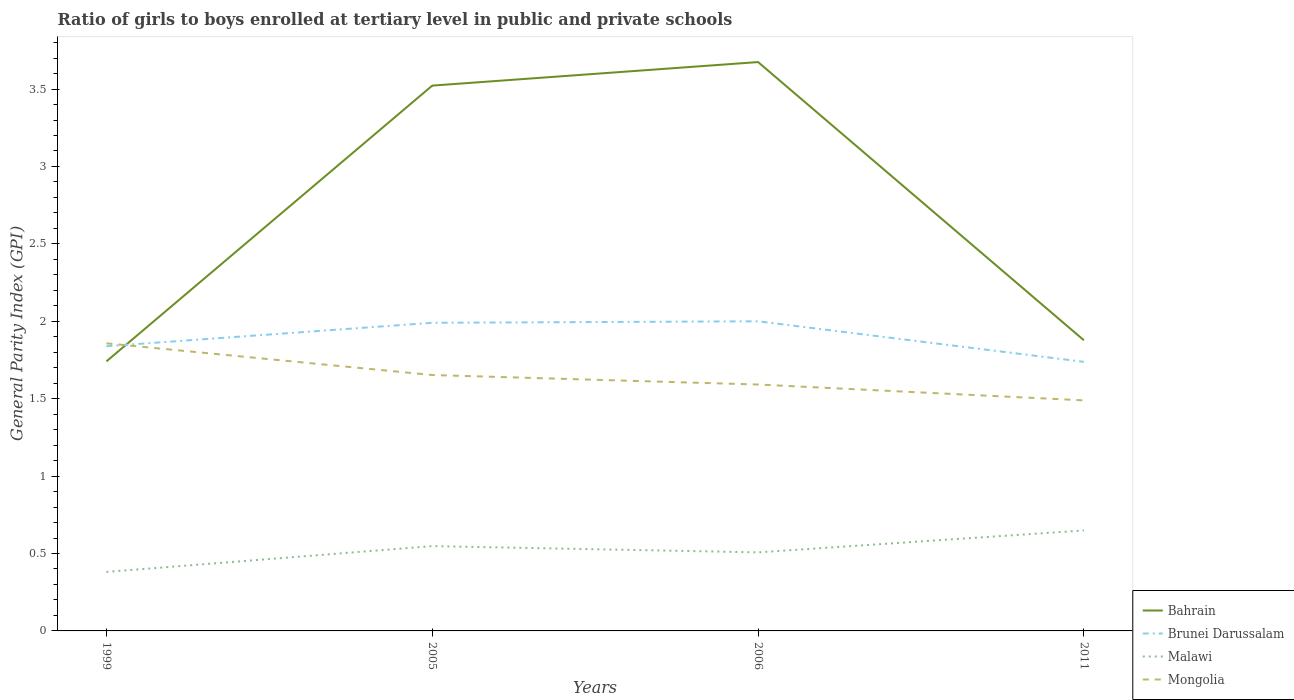How many different coloured lines are there?
Make the answer very short. 4. Is the number of lines equal to the number of legend labels?
Your answer should be very brief. Yes. Across all years, what is the maximum general parity index in Mongolia?
Your response must be concise. 1.49. In which year was the general parity index in Mongolia maximum?
Your response must be concise. 2011. What is the total general parity index in Brunei Darussalam in the graph?
Provide a short and direct response. 0.26. What is the difference between the highest and the second highest general parity index in Mongolia?
Keep it short and to the point. 0.37. Is the general parity index in Bahrain strictly greater than the general parity index in Malawi over the years?
Make the answer very short. No. How many lines are there?
Your response must be concise. 4. How many years are there in the graph?
Provide a succinct answer. 4. What is the difference between two consecutive major ticks on the Y-axis?
Provide a succinct answer. 0.5. Where does the legend appear in the graph?
Your answer should be very brief. Bottom right. How many legend labels are there?
Provide a short and direct response. 4. How are the legend labels stacked?
Ensure brevity in your answer.  Vertical. What is the title of the graph?
Your response must be concise. Ratio of girls to boys enrolled at tertiary level in public and private schools. What is the label or title of the Y-axis?
Your answer should be compact. General Parity Index (GPI). What is the General Parity Index (GPI) in Bahrain in 1999?
Your answer should be very brief. 1.74. What is the General Parity Index (GPI) of Brunei Darussalam in 1999?
Offer a very short reply. 1.84. What is the General Parity Index (GPI) in Malawi in 1999?
Your answer should be compact. 0.38. What is the General Parity Index (GPI) of Mongolia in 1999?
Your answer should be compact. 1.86. What is the General Parity Index (GPI) in Bahrain in 2005?
Offer a terse response. 3.52. What is the General Parity Index (GPI) of Brunei Darussalam in 2005?
Your response must be concise. 1.99. What is the General Parity Index (GPI) in Malawi in 2005?
Offer a very short reply. 0.55. What is the General Parity Index (GPI) in Mongolia in 2005?
Give a very brief answer. 1.65. What is the General Parity Index (GPI) in Bahrain in 2006?
Ensure brevity in your answer.  3.67. What is the General Parity Index (GPI) in Brunei Darussalam in 2006?
Ensure brevity in your answer.  2. What is the General Parity Index (GPI) in Malawi in 2006?
Ensure brevity in your answer.  0.51. What is the General Parity Index (GPI) in Mongolia in 2006?
Your answer should be very brief. 1.59. What is the General Parity Index (GPI) of Bahrain in 2011?
Make the answer very short. 1.88. What is the General Parity Index (GPI) in Brunei Darussalam in 2011?
Ensure brevity in your answer.  1.74. What is the General Parity Index (GPI) of Malawi in 2011?
Make the answer very short. 0.65. What is the General Parity Index (GPI) of Mongolia in 2011?
Your response must be concise. 1.49. Across all years, what is the maximum General Parity Index (GPI) in Bahrain?
Keep it short and to the point. 3.67. Across all years, what is the maximum General Parity Index (GPI) of Brunei Darussalam?
Offer a terse response. 2. Across all years, what is the maximum General Parity Index (GPI) in Malawi?
Make the answer very short. 0.65. Across all years, what is the maximum General Parity Index (GPI) of Mongolia?
Provide a short and direct response. 1.86. Across all years, what is the minimum General Parity Index (GPI) in Bahrain?
Your response must be concise. 1.74. Across all years, what is the minimum General Parity Index (GPI) of Brunei Darussalam?
Make the answer very short. 1.74. Across all years, what is the minimum General Parity Index (GPI) of Malawi?
Ensure brevity in your answer.  0.38. Across all years, what is the minimum General Parity Index (GPI) of Mongolia?
Give a very brief answer. 1.49. What is the total General Parity Index (GPI) in Bahrain in the graph?
Your answer should be compact. 10.82. What is the total General Parity Index (GPI) in Brunei Darussalam in the graph?
Give a very brief answer. 7.57. What is the total General Parity Index (GPI) of Malawi in the graph?
Make the answer very short. 2.09. What is the total General Parity Index (GPI) in Mongolia in the graph?
Offer a very short reply. 6.59. What is the difference between the General Parity Index (GPI) of Bahrain in 1999 and that in 2005?
Your answer should be compact. -1.78. What is the difference between the General Parity Index (GPI) in Brunei Darussalam in 1999 and that in 2005?
Your answer should be compact. -0.15. What is the difference between the General Parity Index (GPI) of Malawi in 1999 and that in 2005?
Your answer should be compact. -0.17. What is the difference between the General Parity Index (GPI) in Mongolia in 1999 and that in 2005?
Provide a short and direct response. 0.2. What is the difference between the General Parity Index (GPI) in Bahrain in 1999 and that in 2006?
Provide a short and direct response. -1.93. What is the difference between the General Parity Index (GPI) of Brunei Darussalam in 1999 and that in 2006?
Offer a very short reply. -0.16. What is the difference between the General Parity Index (GPI) in Malawi in 1999 and that in 2006?
Keep it short and to the point. -0.13. What is the difference between the General Parity Index (GPI) of Mongolia in 1999 and that in 2006?
Provide a succinct answer. 0.27. What is the difference between the General Parity Index (GPI) in Bahrain in 1999 and that in 2011?
Offer a very short reply. -0.14. What is the difference between the General Parity Index (GPI) of Brunei Darussalam in 1999 and that in 2011?
Offer a very short reply. 0.1. What is the difference between the General Parity Index (GPI) of Malawi in 1999 and that in 2011?
Offer a terse response. -0.27. What is the difference between the General Parity Index (GPI) of Mongolia in 1999 and that in 2011?
Give a very brief answer. 0.37. What is the difference between the General Parity Index (GPI) of Bahrain in 2005 and that in 2006?
Offer a very short reply. -0.15. What is the difference between the General Parity Index (GPI) in Brunei Darussalam in 2005 and that in 2006?
Keep it short and to the point. -0.01. What is the difference between the General Parity Index (GPI) in Malawi in 2005 and that in 2006?
Keep it short and to the point. 0.04. What is the difference between the General Parity Index (GPI) of Mongolia in 2005 and that in 2006?
Keep it short and to the point. 0.06. What is the difference between the General Parity Index (GPI) of Bahrain in 2005 and that in 2011?
Offer a terse response. 1.64. What is the difference between the General Parity Index (GPI) of Brunei Darussalam in 2005 and that in 2011?
Ensure brevity in your answer.  0.25. What is the difference between the General Parity Index (GPI) of Malawi in 2005 and that in 2011?
Your answer should be very brief. -0.1. What is the difference between the General Parity Index (GPI) of Mongolia in 2005 and that in 2011?
Provide a short and direct response. 0.16. What is the difference between the General Parity Index (GPI) of Bahrain in 2006 and that in 2011?
Give a very brief answer. 1.8. What is the difference between the General Parity Index (GPI) of Brunei Darussalam in 2006 and that in 2011?
Provide a succinct answer. 0.26. What is the difference between the General Parity Index (GPI) in Malawi in 2006 and that in 2011?
Provide a short and direct response. -0.14. What is the difference between the General Parity Index (GPI) of Mongolia in 2006 and that in 2011?
Make the answer very short. 0.1. What is the difference between the General Parity Index (GPI) of Bahrain in 1999 and the General Parity Index (GPI) of Brunei Darussalam in 2005?
Provide a short and direct response. -0.25. What is the difference between the General Parity Index (GPI) in Bahrain in 1999 and the General Parity Index (GPI) in Malawi in 2005?
Offer a terse response. 1.19. What is the difference between the General Parity Index (GPI) in Bahrain in 1999 and the General Parity Index (GPI) in Mongolia in 2005?
Your answer should be compact. 0.09. What is the difference between the General Parity Index (GPI) of Brunei Darussalam in 1999 and the General Parity Index (GPI) of Malawi in 2005?
Give a very brief answer. 1.29. What is the difference between the General Parity Index (GPI) of Brunei Darussalam in 1999 and the General Parity Index (GPI) of Mongolia in 2005?
Offer a very short reply. 0.19. What is the difference between the General Parity Index (GPI) of Malawi in 1999 and the General Parity Index (GPI) of Mongolia in 2005?
Your answer should be compact. -1.27. What is the difference between the General Parity Index (GPI) in Bahrain in 1999 and the General Parity Index (GPI) in Brunei Darussalam in 2006?
Your answer should be compact. -0.26. What is the difference between the General Parity Index (GPI) of Bahrain in 1999 and the General Parity Index (GPI) of Malawi in 2006?
Make the answer very short. 1.23. What is the difference between the General Parity Index (GPI) in Bahrain in 1999 and the General Parity Index (GPI) in Mongolia in 2006?
Offer a very short reply. 0.15. What is the difference between the General Parity Index (GPI) in Brunei Darussalam in 1999 and the General Parity Index (GPI) in Malawi in 2006?
Provide a short and direct response. 1.33. What is the difference between the General Parity Index (GPI) in Brunei Darussalam in 1999 and the General Parity Index (GPI) in Mongolia in 2006?
Make the answer very short. 0.25. What is the difference between the General Parity Index (GPI) of Malawi in 1999 and the General Parity Index (GPI) of Mongolia in 2006?
Make the answer very short. -1.21. What is the difference between the General Parity Index (GPI) in Bahrain in 1999 and the General Parity Index (GPI) in Brunei Darussalam in 2011?
Keep it short and to the point. 0. What is the difference between the General Parity Index (GPI) of Bahrain in 1999 and the General Parity Index (GPI) of Malawi in 2011?
Provide a succinct answer. 1.09. What is the difference between the General Parity Index (GPI) of Bahrain in 1999 and the General Parity Index (GPI) of Mongolia in 2011?
Make the answer very short. 0.25. What is the difference between the General Parity Index (GPI) of Brunei Darussalam in 1999 and the General Parity Index (GPI) of Malawi in 2011?
Your answer should be very brief. 1.19. What is the difference between the General Parity Index (GPI) of Brunei Darussalam in 1999 and the General Parity Index (GPI) of Mongolia in 2011?
Your answer should be very brief. 0.35. What is the difference between the General Parity Index (GPI) of Malawi in 1999 and the General Parity Index (GPI) of Mongolia in 2011?
Give a very brief answer. -1.11. What is the difference between the General Parity Index (GPI) in Bahrain in 2005 and the General Parity Index (GPI) in Brunei Darussalam in 2006?
Your response must be concise. 1.52. What is the difference between the General Parity Index (GPI) of Bahrain in 2005 and the General Parity Index (GPI) of Malawi in 2006?
Your response must be concise. 3.01. What is the difference between the General Parity Index (GPI) of Bahrain in 2005 and the General Parity Index (GPI) of Mongolia in 2006?
Provide a succinct answer. 1.93. What is the difference between the General Parity Index (GPI) in Brunei Darussalam in 2005 and the General Parity Index (GPI) in Malawi in 2006?
Make the answer very short. 1.48. What is the difference between the General Parity Index (GPI) of Brunei Darussalam in 2005 and the General Parity Index (GPI) of Mongolia in 2006?
Give a very brief answer. 0.4. What is the difference between the General Parity Index (GPI) in Malawi in 2005 and the General Parity Index (GPI) in Mongolia in 2006?
Make the answer very short. -1.04. What is the difference between the General Parity Index (GPI) in Bahrain in 2005 and the General Parity Index (GPI) in Brunei Darussalam in 2011?
Give a very brief answer. 1.78. What is the difference between the General Parity Index (GPI) in Bahrain in 2005 and the General Parity Index (GPI) in Malawi in 2011?
Provide a succinct answer. 2.87. What is the difference between the General Parity Index (GPI) of Bahrain in 2005 and the General Parity Index (GPI) of Mongolia in 2011?
Give a very brief answer. 2.03. What is the difference between the General Parity Index (GPI) in Brunei Darussalam in 2005 and the General Parity Index (GPI) in Malawi in 2011?
Provide a short and direct response. 1.34. What is the difference between the General Parity Index (GPI) of Brunei Darussalam in 2005 and the General Parity Index (GPI) of Mongolia in 2011?
Your answer should be compact. 0.5. What is the difference between the General Parity Index (GPI) of Malawi in 2005 and the General Parity Index (GPI) of Mongolia in 2011?
Your answer should be very brief. -0.94. What is the difference between the General Parity Index (GPI) in Bahrain in 2006 and the General Parity Index (GPI) in Brunei Darussalam in 2011?
Give a very brief answer. 1.94. What is the difference between the General Parity Index (GPI) in Bahrain in 2006 and the General Parity Index (GPI) in Malawi in 2011?
Ensure brevity in your answer.  3.03. What is the difference between the General Parity Index (GPI) in Bahrain in 2006 and the General Parity Index (GPI) in Mongolia in 2011?
Provide a succinct answer. 2.19. What is the difference between the General Parity Index (GPI) in Brunei Darussalam in 2006 and the General Parity Index (GPI) in Malawi in 2011?
Offer a very short reply. 1.35. What is the difference between the General Parity Index (GPI) in Brunei Darussalam in 2006 and the General Parity Index (GPI) in Mongolia in 2011?
Offer a terse response. 0.51. What is the difference between the General Parity Index (GPI) in Malawi in 2006 and the General Parity Index (GPI) in Mongolia in 2011?
Offer a very short reply. -0.98. What is the average General Parity Index (GPI) in Bahrain per year?
Offer a very short reply. 2.7. What is the average General Parity Index (GPI) in Brunei Darussalam per year?
Offer a terse response. 1.89. What is the average General Parity Index (GPI) of Malawi per year?
Offer a terse response. 0.52. What is the average General Parity Index (GPI) in Mongolia per year?
Ensure brevity in your answer.  1.65. In the year 1999, what is the difference between the General Parity Index (GPI) of Bahrain and General Parity Index (GPI) of Brunei Darussalam?
Provide a succinct answer. -0.1. In the year 1999, what is the difference between the General Parity Index (GPI) in Bahrain and General Parity Index (GPI) in Malawi?
Your answer should be very brief. 1.36. In the year 1999, what is the difference between the General Parity Index (GPI) in Bahrain and General Parity Index (GPI) in Mongolia?
Make the answer very short. -0.12. In the year 1999, what is the difference between the General Parity Index (GPI) of Brunei Darussalam and General Parity Index (GPI) of Malawi?
Offer a terse response. 1.46. In the year 1999, what is the difference between the General Parity Index (GPI) of Brunei Darussalam and General Parity Index (GPI) of Mongolia?
Provide a succinct answer. -0.02. In the year 1999, what is the difference between the General Parity Index (GPI) of Malawi and General Parity Index (GPI) of Mongolia?
Make the answer very short. -1.48. In the year 2005, what is the difference between the General Parity Index (GPI) of Bahrain and General Parity Index (GPI) of Brunei Darussalam?
Offer a very short reply. 1.53. In the year 2005, what is the difference between the General Parity Index (GPI) in Bahrain and General Parity Index (GPI) in Malawi?
Your response must be concise. 2.97. In the year 2005, what is the difference between the General Parity Index (GPI) in Bahrain and General Parity Index (GPI) in Mongolia?
Your answer should be very brief. 1.87. In the year 2005, what is the difference between the General Parity Index (GPI) in Brunei Darussalam and General Parity Index (GPI) in Malawi?
Provide a succinct answer. 1.44. In the year 2005, what is the difference between the General Parity Index (GPI) in Brunei Darussalam and General Parity Index (GPI) in Mongolia?
Make the answer very short. 0.34. In the year 2005, what is the difference between the General Parity Index (GPI) of Malawi and General Parity Index (GPI) of Mongolia?
Your response must be concise. -1.11. In the year 2006, what is the difference between the General Parity Index (GPI) in Bahrain and General Parity Index (GPI) in Brunei Darussalam?
Your answer should be very brief. 1.67. In the year 2006, what is the difference between the General Parity Index (GPI) in Bahrain and General Parity Index (GPI) in Malawi?
Your answer should be compact. 3.17. In the year 2006, what is the difference between the General Parity Index (GPI) in Bahrain and General Parity Index (GPI) in Mongolia?
Offer a very short reply. 2.08. In the year 2006, what is the difference between the General Parity Index (GPI) in Brunei Darussalam and General Parity Index (GPI) in Malawi?
Ensure brevity in your answer.  1.49. In the year 2006, what is the difference between the General Parity Index (GPI) in Brunei Darussalam and General Parity Index (GPI) in Mongolia?
Offer a terse response. 0.41. In the year 2006, what is the difference between the General Parity Index (GPI) of Malawi and General Parity Index (GPI) of Mongolia?
Your answer should be compact. -1.08. In the year 2011, what is the difference between the General Parity Index (GPI) of Bahrain and General Parity Index (GPI) of Brunei Darussalam?
Ensure brevity in your answer.  0.14. In the year 2011, what is the difference between the General Parity Index (GPI) in Bahrain and General Parity Index (GPI) in Malawi?
Ensure brevity in your answer.  1.23. In the year 2011, what is the difference between the General Parity Index (GPI) of Bahrain and General Parity Index (GPI) of Mongolia?
Keep it short and to the point. 0.39. In the year 2011, what is the difference between the General Parity Index (GPI) in Brunei Darussalam and General Parity Index (GPI) in Malawi?
Give a very brief answer. 1.09. In the year 2011, what is the difference between the General Parity Index (GPI) in Brunei Darussalam and General Parity Index (GPI) in Mongolia?
Give a very brief answer. 0.25. In the year 2011, what is the difference between the General Parity Index (GPI) of Malawi and General Parity Index (GPI) of Mongolia?
Make the answer very short. -0.84. What is the ratio of the General Parity Index (GPI) in Bahrain in 1999 to that in 2005?
Offer a terse response. 0.49. What is the ratio of the General Parity Index (GPI) of Brunei Darussalam in 1999 to that in 2005?
Make the answer very short. 0.92. What is the ratio of the General Parity Index (GPI) in Malawi in 1999 to that in 2005?
Provide a succinct answer. 0.7. What is the ratio of the General Parity Index (GPI) of Mongolia in 1999 to that in 2005?
Provide a succinct answer. 1.12. What is the ratio of the General Parity Index (GPI) of Bahrain in 1999 to that in 2006?
Offer a very short reply. 0.47. What is the ratio of the General Parity Index (GPI) of Brunei Darussalam in 1999 to that in 2006?
Make the answer very short. 0.92. What is the ratio of the General Parity Index (GPI) in Malawi in 1999 to that in 2006?
Your answer should be very brief. 0.75. What is the ratio of the General Parity Index (GPI) in Mongolia in 1999 to that in 2006?
Give a very brief answer. 1.17. What is the ratio of the General Parity Index (GPI) of Bahrain in 1999 to that in 2011?
Provide a succinct answer. 0.93. What is the ratio of the General Parity Index (GPI) in Brunei Darussalam in 1999 to that in 2011?
Your answer should be compact. 1.06. What is the ratio of the General Parity Index (GPI) in Malawi in 1999 to that in 2011?
Offer a terse response. 0.59. What is the ratio of the General Parity Index (GPI) of Mongolia in 1999 to that in 2011?
Give a very brief answer. 1.25. What is the ratio of the General Parity Index (GPI) of Bahrain in 2005 to that in 2006?
Ensure brevity in your answer.  0.96. What is the ratio of the General Parity Index (GPI) in Brunei Darussalam in 2005 to that in 2006?
Offer a terse response. 1. What is the ratio of the General Parity Index (GPI) of Malawi in 2005 to that in 2006?
Make the answer very short. 1.08. What is the ratio of the General Parity Index (GPI) of Mongolia in 2005 to that in 2006?
Make the answer very short. 1.04. What is the ratio of the General Parity Index (GPI) in Bahrain in 2005 to that in 2011?
Offer a terse response. 1.88. What is the ratio of the General Parity Index (GPI) of Brunei Darussalam in 2005 to that in 2011?
Offer a very short reply. 1.15. What is the ratio of the General Parity Index (GPI) in Malawi in 2005 to that in 2011?
Your answer should be compact. 0.84. What is the ratio of the General Parity Index (GPI) in Mongolia in 2005 to that in 2011?
Your response must be concise. 1.11. What is the ratio of the General Parity Index (GPI) of Bahrain in 2006 to that in 2011?
Give a very brief answer. 1.96. What is the ratio of the General Parity Index (GPI) in Brunei Darussalam in 2006 to that in 2011?
Your answer should be very brief. 1.15. What is the ratio of the General Parity Index (GPI) in Malawi in 2006 to that in 2011?
Provide a succinct answer. 0.78. What is the ratio of the General Parity Index (GPI) in Mongolia in 2006 to that in 2011?
Your answer should be very brief. 1.07. What is the difference between the highest and the second highest General Parity Index (GPI) of Bahrain?
Your answer should be very brief. 0.15. What is the difference between the highest and the second highest General Parity Index (GPI) of Brunei Darussalam?
Make the answer very short. 0.01. What is the difference between the highest and the second highest General Parity Index (GPI) in Malawi?
Your response must be concise. 0.1. What is the difference between the highest and the second highest General Parity Index (GPI) in Mongolia?
Make the answer very short. 0.2. What is the difference between the highest and the lowest General Parity Index (GPI) of Bahrain?
Make the answer very short. 1.93. What is the difference between the highest and the lowest General Parity Index (GPI) of Brunei Darussalam?
Provide a succinct answer. 0.26. What is the difference between the highest and the lowest General Parity Index (GPI) of Malawi?
Ensure brevity in your answer.  0.27. What is the difference between the highest and the lowest General Parity Index (GPI) in Mongolia?
Provide a short and direct response. 0.37. 